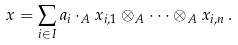<formula> <loc_0><loc_0><loc_500><loc_500>x = \sum _ { i \in I } a _ { i } \cdot _ { A } x _ { i , 1 } \otimes _ { A } \cdots \otimes _ { A } x _ { i , n } \, .</formula> 